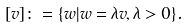<formula> <loc_0><loc_0><loc_500><loc_500>[ v ] \colon = \{ w | w = \lambda v , \lambda > 0 \} .</formula> 